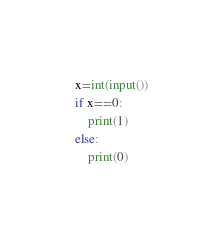<code> <loc_0><loc_0><loc_500><loc_500><_Python_>x=int(input())
if x==0:
    print(1)
else:
    print(0)</code> 